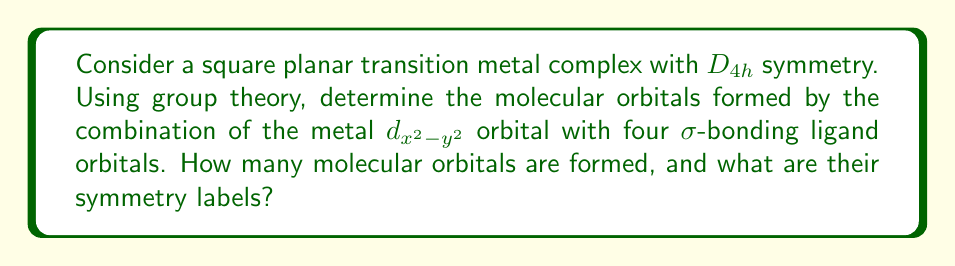What is the answer to this math problem? Let's approach this step-by-step, using an analogy to a chemical reaction:

1) First, we need to identify the symmetry of the orbitals involved:
   - The metal $d_{x^2-y^2}$ orbital transforms as $b_{1g}$ in $D_{4h}$ symmetry.
   - The four $\sigma$-bonding ligand orbitals form a basis for the $a_{1g} + b_{1g} + e_u$ representation.

2) Now, we can think of these orbitals as reactants in a chemical equation. The "products" will be our molecular orbitals.

3) To determine the number and symmetry of the molecular orbitals, we need to take the direct sum of these representations:
   $$(b_{1g}) \oplus (a_{1g} + b_{1g} + e_u)$$

4) This is analogous to combining reagents in a chemical reaction. The result gives us:
   $$a_{1g} + 2b_{1g} + e_u$$

5) Each term in this sum corresponds to a molecular orbital:
   - $a_{1g}$: One molecular orbital with $a_{1g}$ symmetry
   - $2b_{1g}$: Two molecular orbitals with $b_{1g}$ symmetry
   - $e_u$: One doubly degenerate molecular orbital with $e_u$ symmetry

6) Counting these up, we have a total of 5 molecular orbitals (remembering that $e_u$ represents two degenerate orbitals).

This process is similar to balancing a chemical equation, where we ensure that the "reactant" orbitals are fully accounted for in the "product" molecular orbitals.
Answer: 5 molecular orbitals: $a_{1g}$, $2b_{1g}$, $e_u$ 